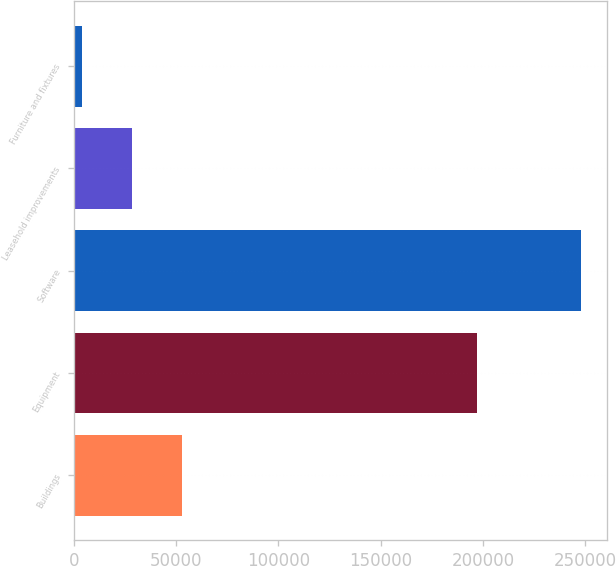<chart> <loc_0><loc_0><loc_500><loc_500><bar_chart><fcel>Buildings<fcel>Equipment<fcel>Software<fcel>Leasehold improvements<fcel>Furniture and fixtures<nl><fcel>52591.4<fcel>197186<fcel>248137<fcel>28148.2<fcel>3705<nl></chart> 